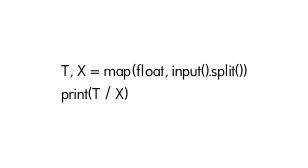Convert code to text. <code><loc_0><loc_0><loc_500><loc_500><_Python_>T, X = map(float, input().split())
print(T / X)</code> 